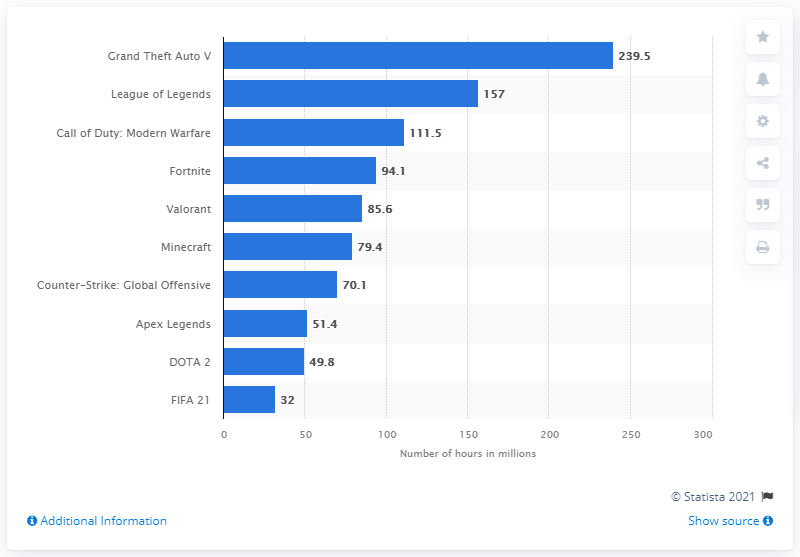Point out several critical features in this image. In April 2021, League of Legends generated a total of 157 viewing hours. The average of DOTA 2 and Fifa 21 is 40.9. Grand Theft Auto V was the leading gaming content on Twitch worldwide in April 2021. Grand Theft Auto V was the most popular title on Twitch in April 2021. Grand Theft Auto V generated approximately 239.5 million viewing hours on Twitch in April 2021. 